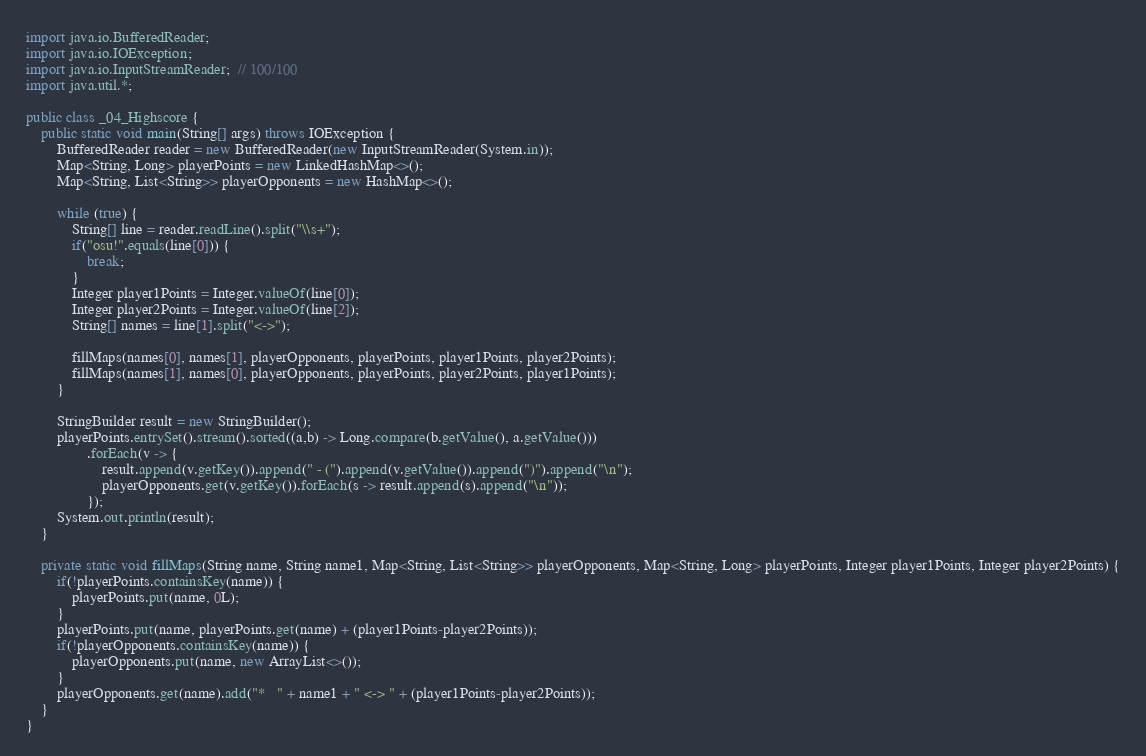<code> <loc_0><loc_0><loc_500><loc_500><_Java_>import java.io.BufferedReader;
import java.io.IOException;
import java.io.InputStreamReader;  // 100/100
import java.util.*;

public class _04_Highscore {
    public static void main(String[] args) throws IOException {
        BufferedReader reader = new BufferedReader(new InputStreamReader(System.in));
        Map<String, Long> playerPoints = new LinkedHashMap<>();
        Map<String, List<String>> playerOpponents = new HashMap<>();

        while (true) {
            String[] line = reader.readLine().split("\\s+");
            if("osu!".equals(line[0])) {
                break;
            }
            Integer player1Points = Integer.valueOf(line[0]);
            Integer player2Points = Integer.valueOf(line[2]);
            String[] names = line[1].split("<->");

            fillMaps(names[0], names[1], playerOpponents, playerPoints, player1Points, player2Points);
            fillMaps(names[1], names[0], playerOpponents, playerPoints, player2Points, player1Points);
        }

        StringBuilder result = new StringBuilder();
        playerPoints.entrySet().stream().sorted((a,b) -> Long.compare(b.getValue(), a.getValue()))
                .forEach(v -> {
                    result.append(v.getKey()).append(" - (").append(v.getValue()).append(")").append("\n");
                    playerOpponents.get(v.getKey()).forEach(s -> result.append(s).append("\n"));
                });
        System.out.println(result);
    }

    private static void fillMaps(String name, String name1, Map<String, List<String>> playerOpponents, Map<String, Long> playerPoints, Integer player1Points, Integer player2Points) {
        if(!playerPoints.containsKey(name)) {
            playerPoints.put(name, 0L);
        }
        playerPoints.put(name, playerPoints.get(name) + (player1Points-player2Points));
        if(!playerOpponents.containsKey(name)) {
            playerOpponents.put(name, new ArrayList<>());
        }
        playerOpponents.get(name).add("*   " + name1 + " <-> " + (player1Points-player2Points));
    }
}

</code> 